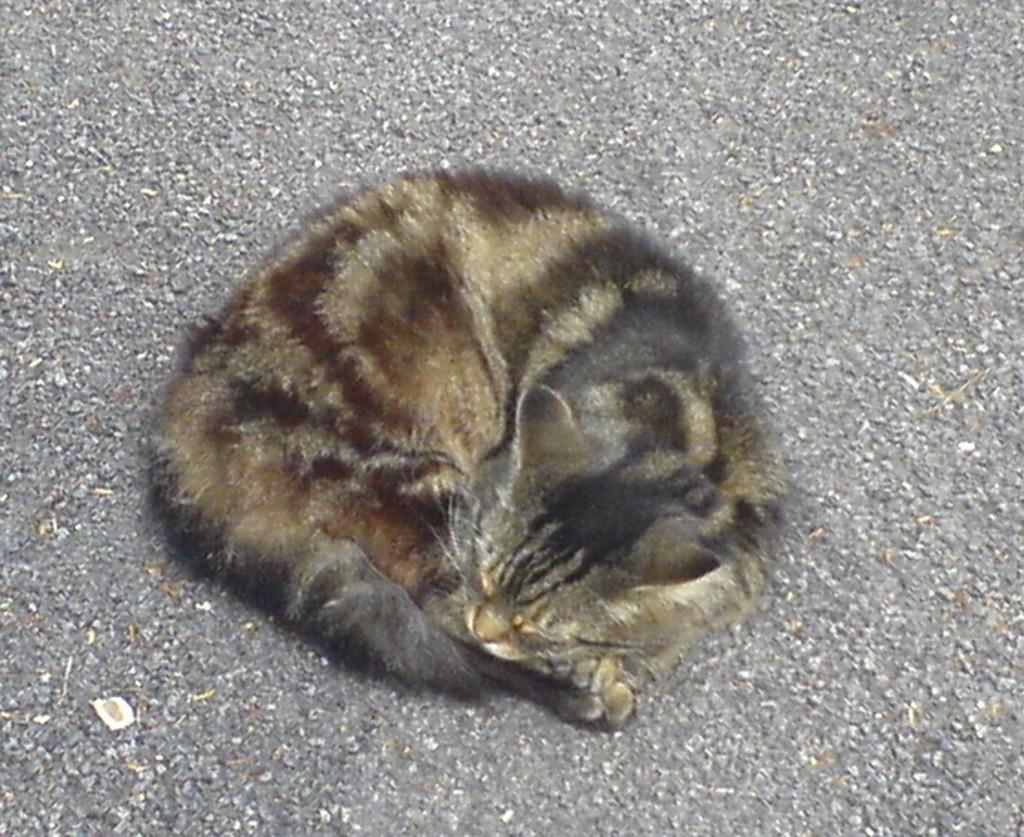Where was the image taken? The image was taken outdoors. What can be seen at the bottom of the image? There is a road at the bottom of the image. What animal is present in the middle of the road? There is a cat in the middle of the road. What type of lamp can be seen illuminating the cat in the image? There is no lamp present in the image; it is taken outdoors, and the cat is in the middle of the road. 